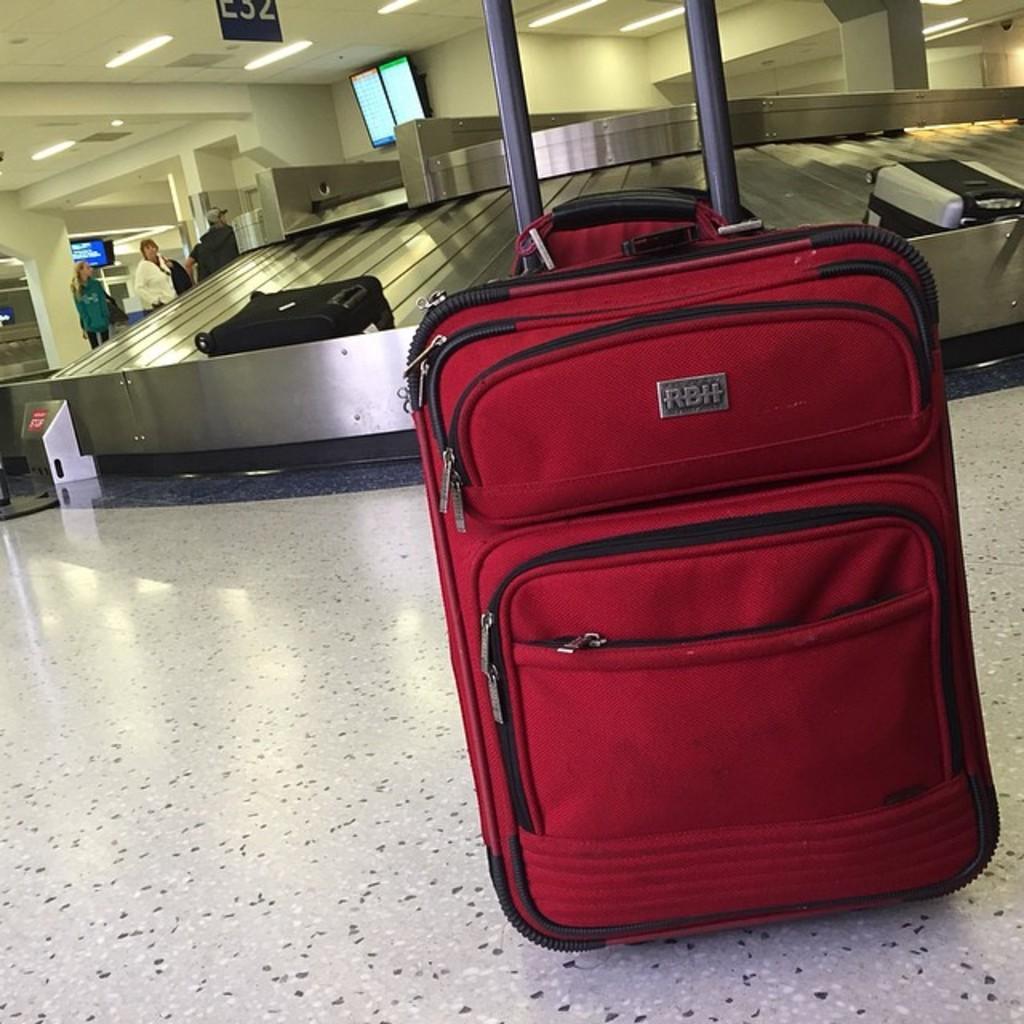How would you summarize this image in a sentence or two? In this picture there is a red luggage bag. There are three standing in the background. There is a black and grey luggage bag. There are some lights to the roof. There is a screen on the top. 